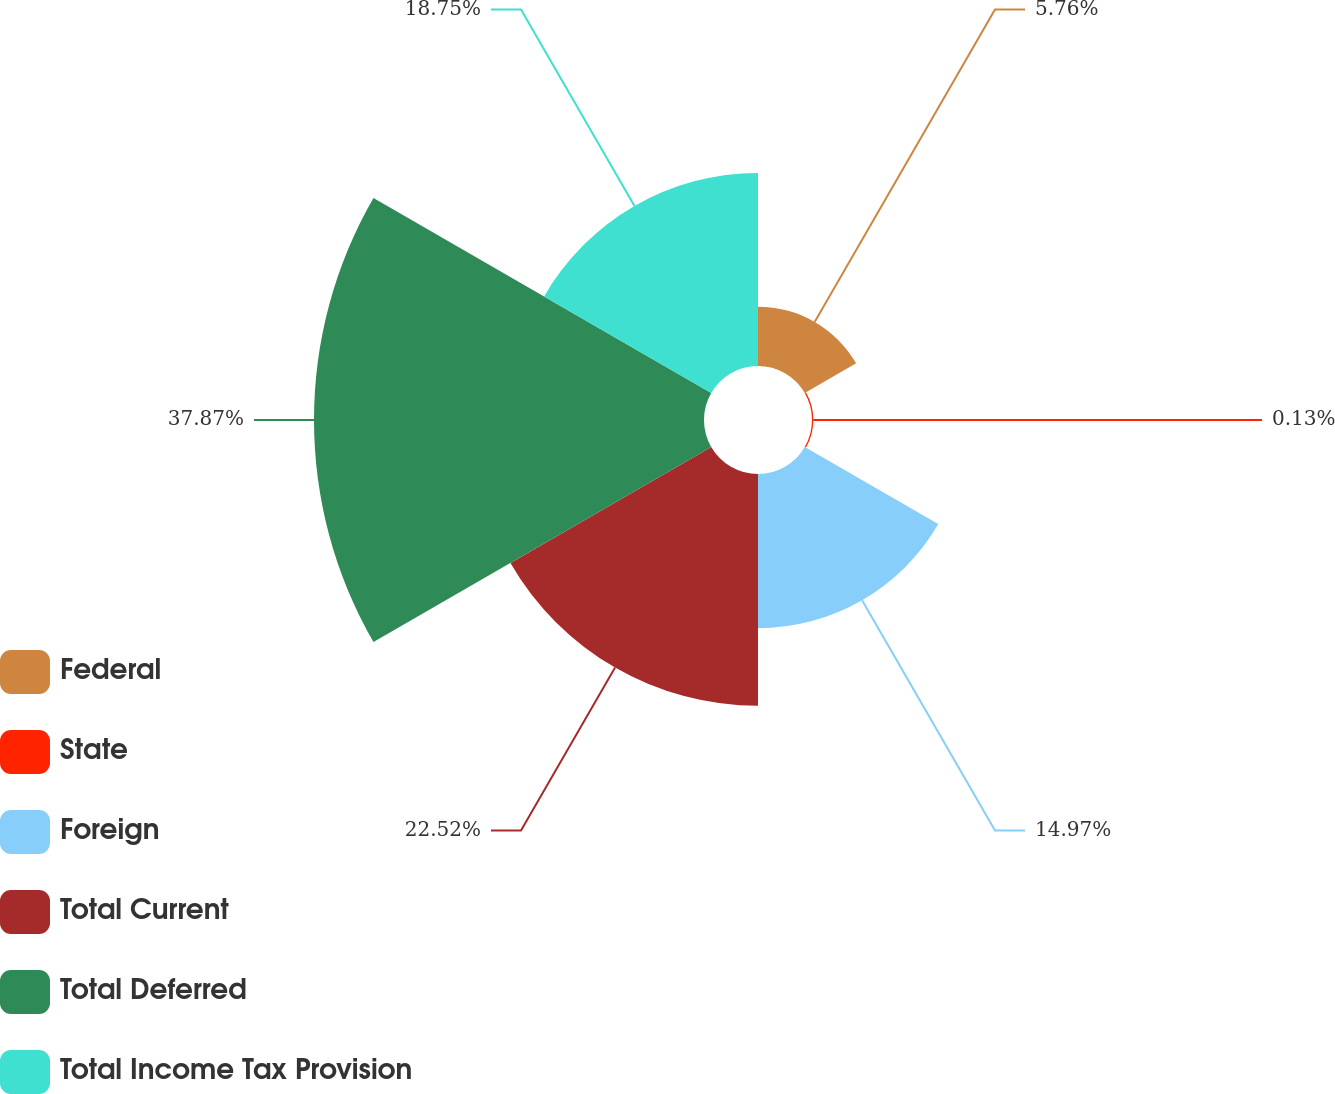<chart> <loc_0><loc_0><loc_500><loc_500><pie_chart><fcel>Federal<fcel>State<fcel>Foreign<fcel>Total Current<fcel>Total Deferred<fcel>Total Income Tax Provision<nl><fcel>5.76%<fcel>0.13%<fcel>14.97%<fcel>22.52%<fcel>37.88%<fcel>18.75%<nl></chart> 